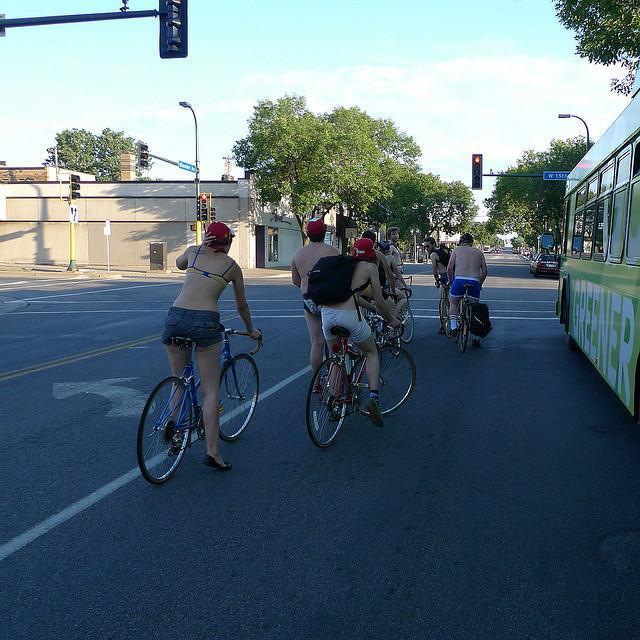How many bicycles are in the picture?
Give a very brief answer. 2. How many people are visible?
Give a very brief answer. 4. How many horses are looking at the camera?
Give a very brief answer. 0. 